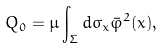Convert formula to latex. <formula><loc_0><loc_0><loc_500><loc_500>Q _ { 0 } = \mu \int _ { \Sigma } d \sigma _ { x } \bar { \varphi } ^ { 2 } ( x ) ,</formula> 